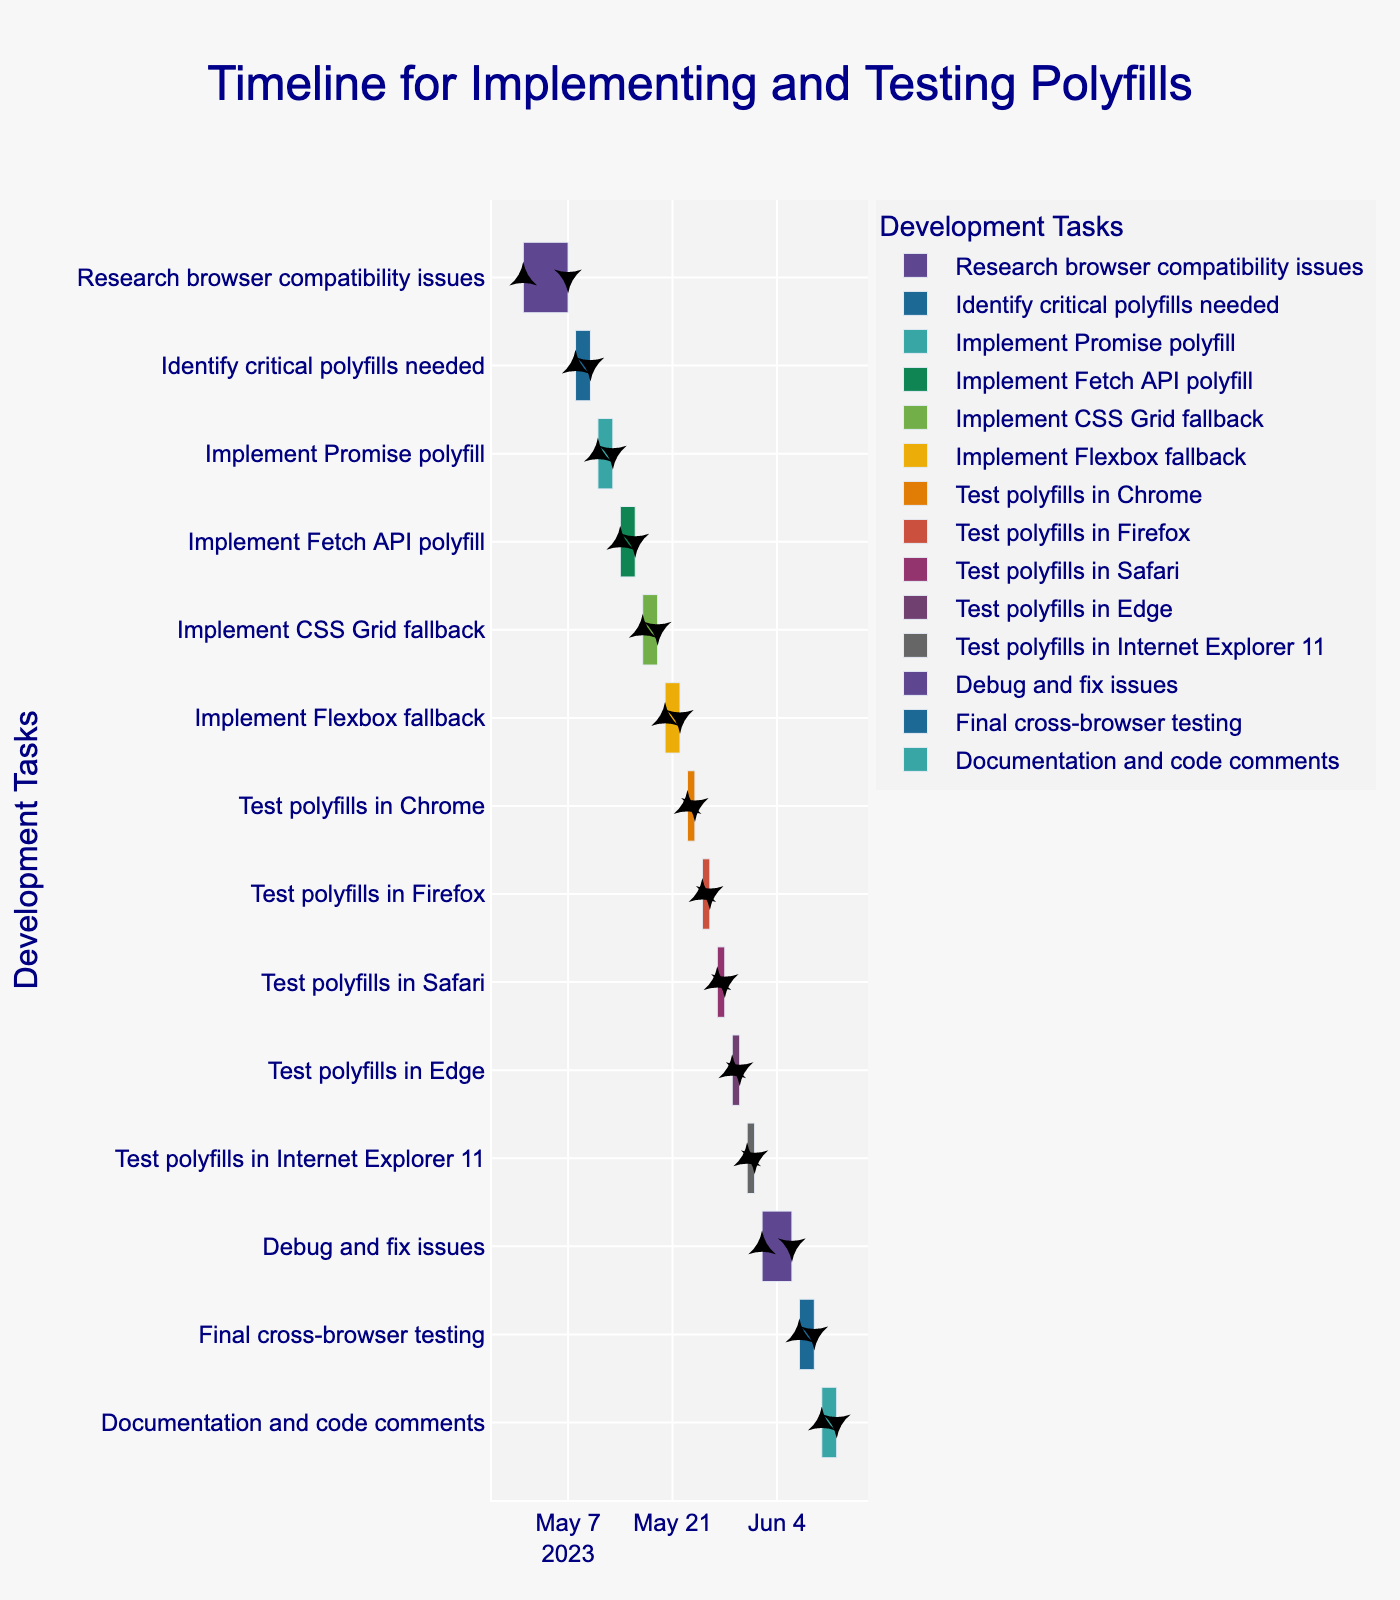What is the title of the Gantt chart? The title of the Gantt chart can be found at the top of the figure. It provides a high-level overview or summary of the chart's purpose.
Answer: Timeline for Implementing and Testing Polyfills How long is the "Research browser compatibility issues" task? To find the duration, look at the start and end dates of the task, and calculate the difference in days. The start date is 2023-05-01 and the end date is 2023-05-07, which gives a duration of 7 days.
Answer: 7 days Which task comes immediately after "Implement Fetch API polyfill"? Look at the sequence of tasks on the y-axis. The task that comes immediately after "Implement Fetch API polyfill" is the next one in the list.
Answer: Implement CSS Grid fallback What is the combined duration of "Test polyfills in Safari" and "Test polyfills in Edge"? Find the individual durations of each task and add them together. Both tasks have a duration of 2 days each, so combined, they take 4 days.
Answer: 4 days Which tasks are tested in browsers before debugging and fixing issues? Look at the sequence of tasks and identify those that involve testing in browsers. These are the tasks tested before "Debug and fix issues".
Answer: Chrome, Firefox, Safari, Edge, Internet Explorer 11 What is the longest task in the Gantt chart? Compare the durations of all tasks. The longest task is the one with the maximum duration. "Debug and fix issues" is the longest, with a duration of 5 days.
Answer: Debug and fix issues During which dates is the "Implement CSS Grid fallback" task scheduled? Look at the timeline bars for "Implement CSS Grid fallback" to identify the start and end dates. It starts on 2023-05-17 and ends on 2023-05-19.
Answer: 2023-05-17 to 2023-05-19 What is the first task to be completed in June? Examine the sequence of tasks and their end dates. The first task to be completed in June is "Test polyfills in Internet Explorer 11", ending on 2023-06-01.
Answer: Test polyfills in Internet Explorer 11 How many days are allocated for final cross-browser testing? Identify the task "Final cross-browser testing" and look at its duration in the chart. The duration is 3 days.
Answer: 3 days What is the total duration from the start of "Research browser compatibility issues" to the end of "Documentation and code comments"? Find the start date of the first task and the end date of the last task, then calculate the total number of days between these dates. From 2023-05-01 to 2023-06-12, the total duration is 43 days.
Answer: 43 days 